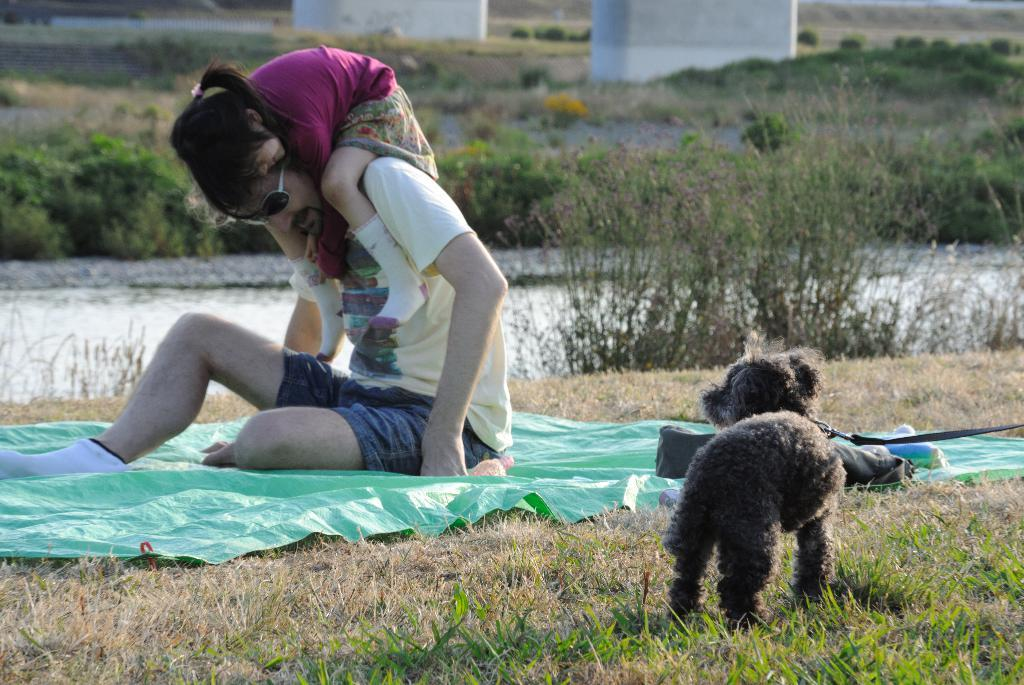What is the man in the image doing? The man is sitting on a cover, and a kid is sitting on his shoulders. What is the surface the man and kid are sitting on? The man is sitting on a cover. What can be seen in the image besides the man and kid? There is grass visible in the image, and there is a kid in the grass. What is visible in the background of the image? There are plants and a wall in the background of the image. How many spiders are crawling on the man's back in the image? There are no spiders visible in the image; the man's back is not shown. Can you touch the leaf on the plant in the background of the image? There is no leaf visible in the image, as the plant in the background is not close enough to be touched. 